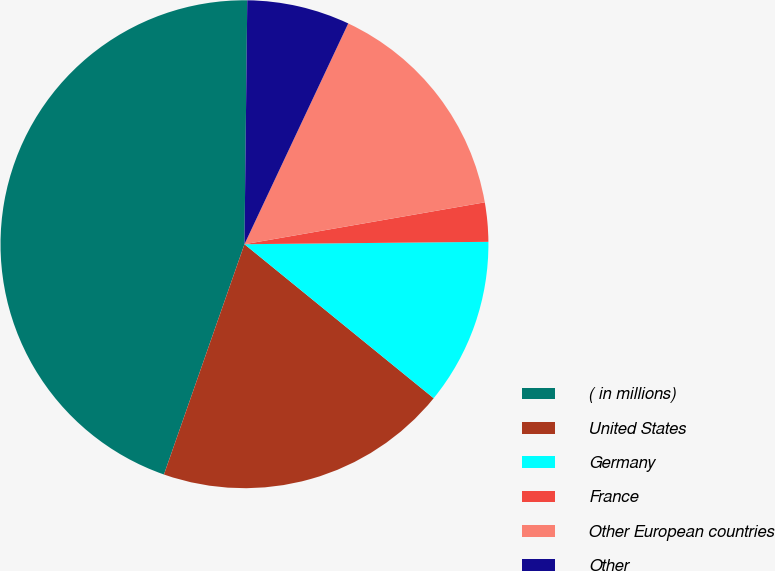<chart> <loc_0><loc_0><loc_500><loc_500><pie_chart><fcel>( in millions)<fcel>United States<fcel>Germany<fcel>France<fcel>Other European countries<fcel>Other<nl><fcel>44.83%<fcel>19.48%<fcel>11.03%<fcel>2.59%<fcel>15.26%<fcel>6.81%<nl></chart> 